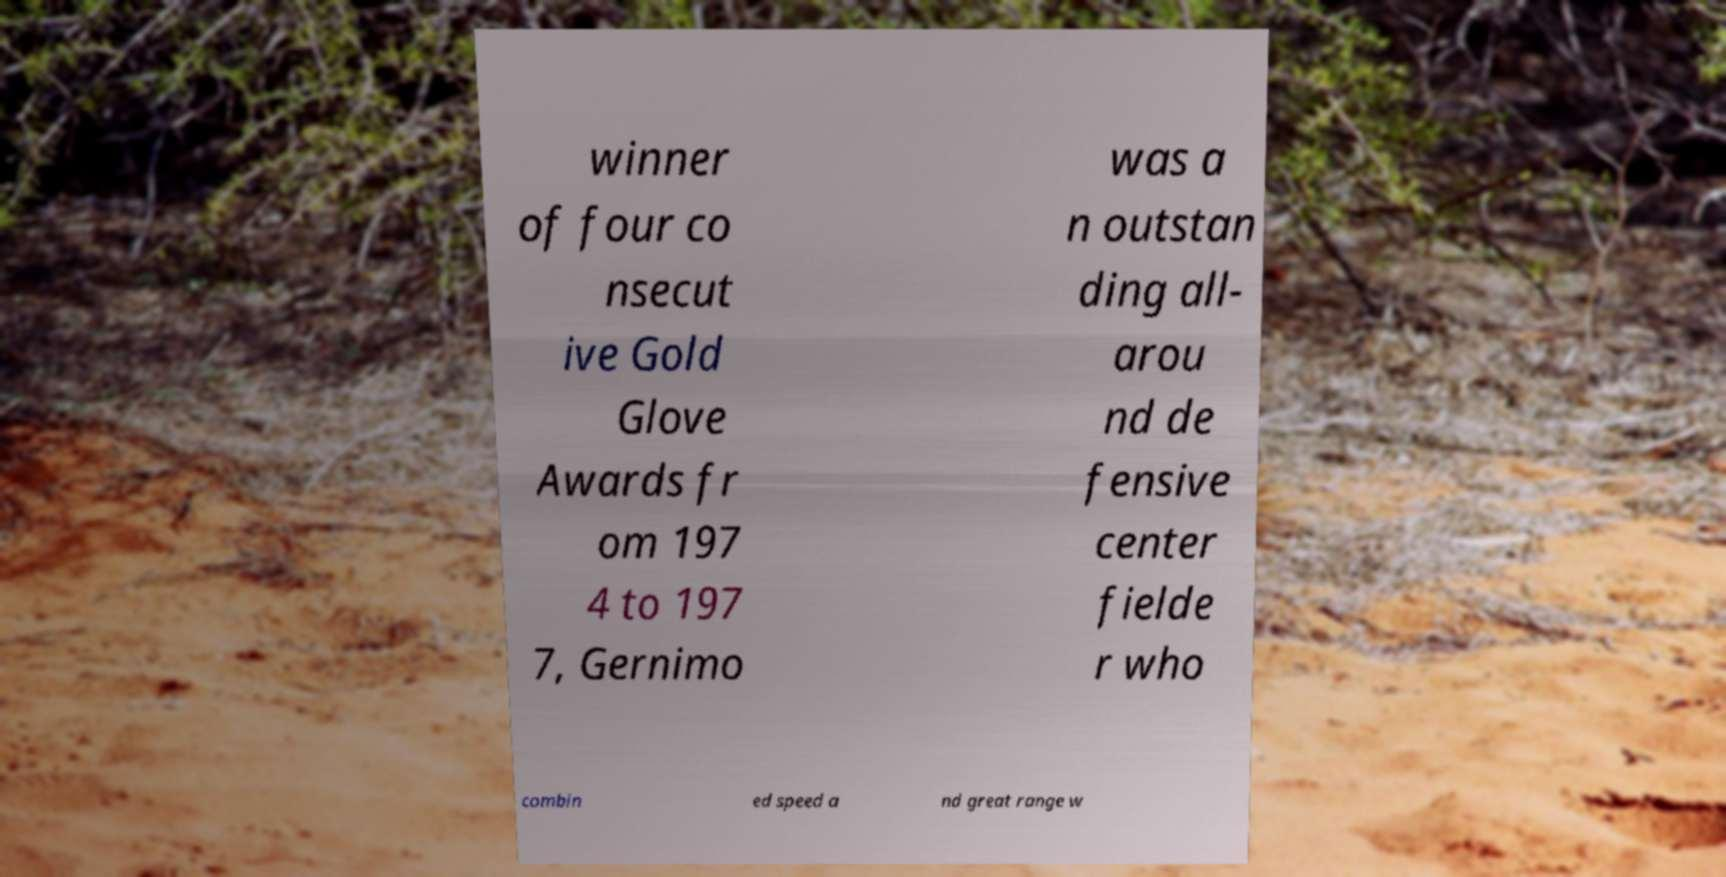Can you accurately transcribe the text from the provided image for me? winner of four co nsecut ive Gold Glove Awards fr om 197 4 to 197 7, Gernimo was a n outstan ding all- arou nd de fensive center fielde r who combin ed speed a nd great range w 